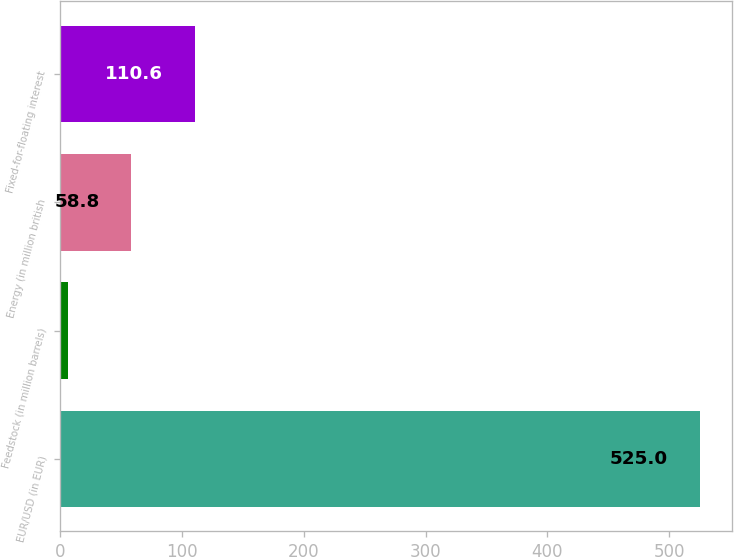Convert chart to OTSL. <chart><loc_0><loc_0><loc_500><loc_500><bar_chart><fcel>EUR/USD (in EUR)<fcel>Feedstock (in million barrels)<fcel>Energy (in million british<fcel>Fixed-for-floating interest<nl><fcel>525<fcel>7<fcel>58.8<fcel>110.6<nl></chart> 